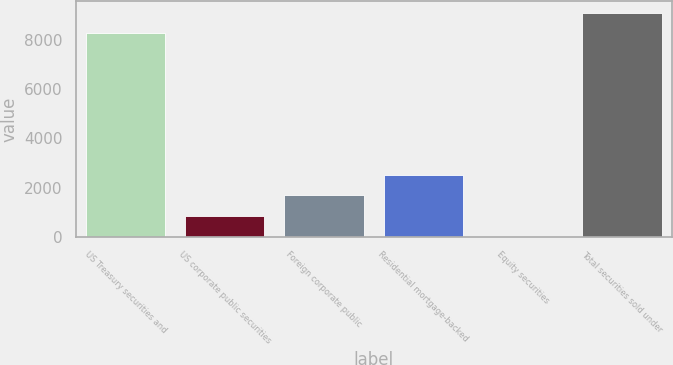Convert chart. <chart><loc_0><loc_0><loc_500><loc_500><bar_chart><fcel>US Treasury securities and<fcel>US corporate public securities<fcel>Foreign corporate public<fcel>Residential mortgage-backed<fcel>Equity securities<fcel>Total securities sold under<nl><fcel>8260<fcel>840.4<fcel>1680.36<fcel>2520.32<fcel>0.44<fcel>9099.96<nl></chart> 